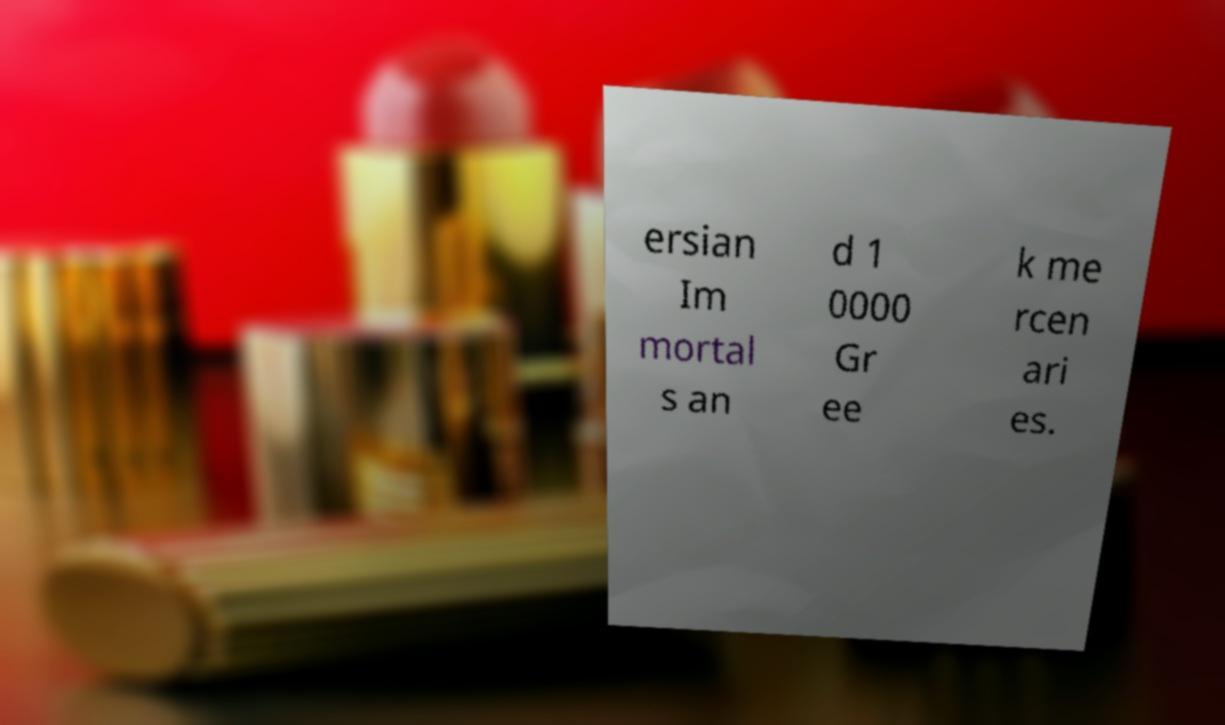What messages or text are displayed in this image? I need them in a readable, typed format. ersian Im mortal s an d 1 0000 Gr ee k me rcen ari es. 